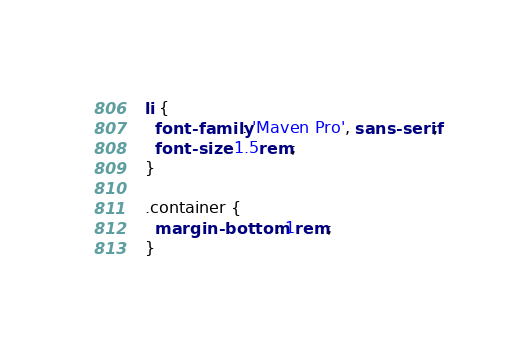Convert code to text. <code><loc_0><loc_0><loc_500><loc_500><_CSS_>
  li {
    font-family: 'Maven Pro', sans-serif;
    font-size: 1.5rem;
  }

  .container {
    margin-bottom: 1rem;
  }</code> 